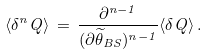<formula> <loc_0><loc_0><loc_500><loc_500>\langle \delta ^ { n } Q \rangle \, = \, \frac { \partial ^ { n - 1 } } { ( \partial \widetilde { \theta } _ { B S } ) ^ { n - 1 } } \langle \delta Q \rangle \, .</formula> 